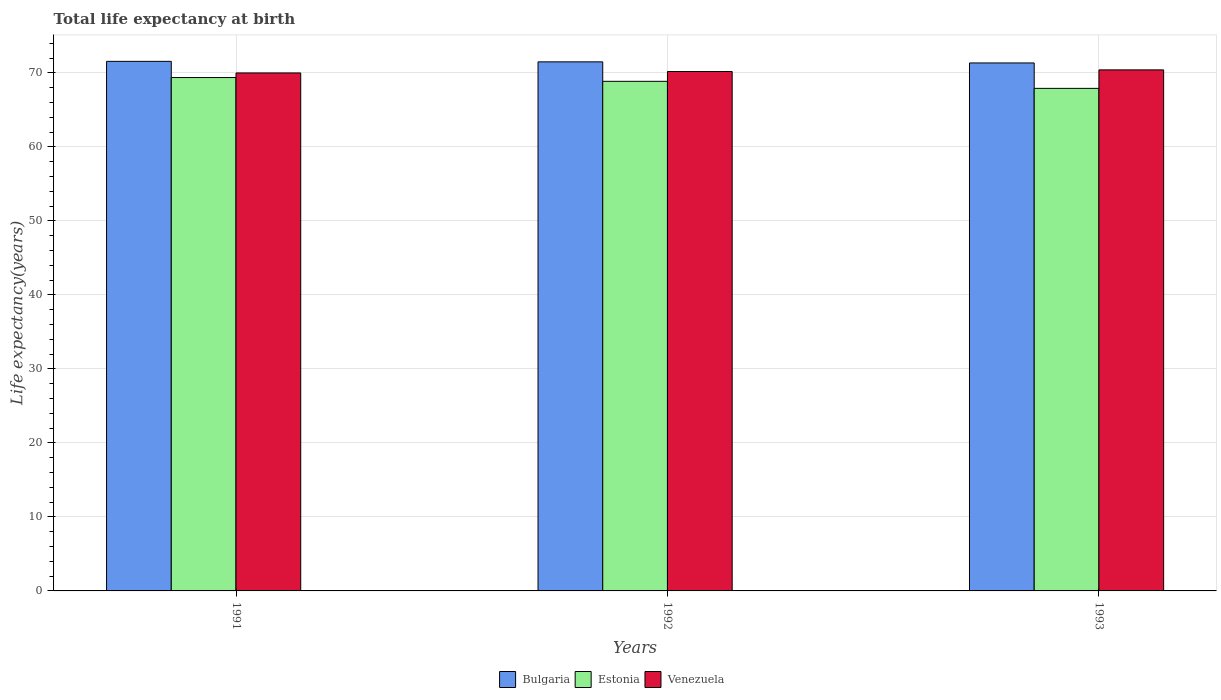How many bars are there on the 2nd tick from the left?
Keep it short and to the point. 3. What is the label of the 1st group of bars from the left?
Your answer should be very brief. 1991. In how many cases, is the number of bars for a given year not equal to the number of legend labels?
Offer a very short reply. 0. What is the life expectancy at birth in in Estonia in 1991?
Keep it short and to the point. 69.37. Across all years, what is the maximum life expectancy at birth in in Venezuela?
Your response must be concise. 70.41. Across all years, what is the minimum life expectancy at birth in in Bulgaria?
Keep it short and to the point. 71.35. In which year was the life expectancy at birth in in Bulgaria maximum?
Provide a short and direct response. 1991. What is the total life expectancy at birth in in Bulgaria in the graph?
Provide a succinct answer. 214.4. What is the difference between the life expectancy at birth in in Venezuela in 1991 and that in 1992?
Offer a terse response. -0.19. What is the difference between the life expectancy at birth in in Venezuela in 1992 and the life expectancy at birth in in Bulgaria in 1991?
Your answer should be compact. -1.37. What is the average life expectancy at birth in in Bulgaria per year?
Give a very brief answer. 71.47. In the year 1993, what is the difference between the life expectancy at birth in in Estonia and life expectancy at birth in in Bulgaria?
Keep it short and to the point. -3.44. In how many years, is the life expectancy at birth in in Bulgaria greater than 4 years?
Give a very brief answer. 3. What is the ratio of the life expectancy at birth in in Estonia in 1992 to that in 1993?
Your response must be concise. 1.01. What is the difference between the highest and the second highest life expectancy at birth in in Bulgaria?
Give a very brief answer. 0.07. What is the difference between the highest and the lowest life expectancy at birth in in Venezuela?
Keep it short and to the point. 0.42. What does the 1st bar from the left in 1991 represents?
Offer a terse response. Bulgaria. What does the 2nd bar from the right in 1993 represents?
Make the answer very short. Estonia. Are all the bars in the graph horizontal?
Your response must be concise. No. How many years are there in the graph?
Provide a succinct answer. 3. Where does the legend appear in the graph?
Offer a terse response. Bottom center. How are the legend labels stacked?
Your response must be concise. Horizontal. What is the title of the graph?
Provide a short and direct response. Total life expectancy at birth. Does "United Kingdom" appear as one of the legend labels in the graph?
Ensure brevity in your answer.  No. What is the label or title of the Y-axis?
Your response must be concise. Life expectancy(years). What is the Life expectancy(years) in Bulgaria in 1991?
Offer a terse response. 71.56. What is the Life expectancy(years) in Estonia in 1991?
Provide a succinct answer. 69.37. What is the Life expectancy(years) in Venezuela in 1991?
Your answer should be compact. 69.99. What is the Life expectancy(years) of Bulgaria in 1992?
Offer a terse response. 71.49. What is the Life expectancy(years) in Estonia in 1992?
Your answer should be compact. 68.86. What is the Life expectancy(years) of Venezuela in 1992?
Offer a very short reply. 70.19. What is the Life expectancy(years) of Bulgaria in 1993?
Make the answer very short. 71.35. What is the Life expectancy(years) in Estonia in 1993?
Your answer should be compact. 67.91. What is the Life expectancy(years) of Venezuela in 1993?
Your answer should be very brief. 70.41. Across all years, what is the maximum Life expectancy(years) of Bulgaria?
Provide a short and direct response. 71.56. Across all years, what is the maximum Life expectancy(years) in Estonia?
Make the answer very short. 69.37. Across all years, what is the maximum Life expectancy(years) of Venezuela?
Keep it short and to the point. 70.41. Across all years, what is the minimum Life expectancy(years) of Bulgaria?
Your response must be concise. 71.35. Across all years, what is the minimum Life expectancy(years) of Estonia?
Provide a short and direct response. 67.91. Across all years, what is the minimum Life expectancy(years) of Venezuela?
Give a very brief answer. 69.99. What is the total Life expectancy(years) in Bulgaria in the graph?
Your answer should be compact. 214.4. What is the total Life expectancy(years) of Estonia in the graph?
Your answer should be compact. 206.15. What is the total Life expectancy(years) of Venezuela in the graph?
Provide a short and direct response. 210.59. What is the difference between the Life expectancy(years) of Bulgaria in 1991 and that in 1992?
Give a very brief answer. 0.07. What is the difference between the Life expectancy(years) of Estonia in 1991 and that in 1992?
Ensure brevity in your answer.  0.51. What is the difference between the Life expectancy(years) in Venezuela in 1991 and that in 1992?
Your answer should be compact. -0.19. What is the difference between the Life expectancy(years) of Bulgaria in 1991 and that in 1993?
Your answer should be compact. 0.21. What is the difference between the Life expectancy(years) of Estonia in 1991 and that in 1993?
Keep it short and to the point. 1.46. What is the difference between the Life expectancy(years) in Venezuela in 1991 and that in 1993?
Keep it short and to the point. -0.41. What is the difference between the Life expectancy(years) in Bulgaria in 1992 and that in 1993?
Your answer should be very brief. 0.15. What is the difference between the Life expectancy(years) in Estonia in 1992 and that in 1993?
Your response must be concise. 0.95. What is the difference between the Life expectancy(years) of Venezuela in 1992 and that in 1993?
Your answer should be compact. -0.22. What is the difference between the Life expectancy(years) in Bulgaria in 1991 and the Life expectancy(years) in Estonia in 1992?
Offer a very short reply. 2.7. What is the difference between the Life expectancy(years) in Bulgaria in 1991 and the Life expectancy(years) in Venezuela in 1992?
Give a very brief answer. 1.37. What is the difference between the Life expectancy(years) in Estonia in 1991 and the Life expectancy(years) in Venezuela in 1992?
Provide a short and direct response. -0.81. What is the difference between the Life expectancy(years) in Bulgaria in 1991 and the Life expectancy(years) in Estonia in 1993?
Give a very brief answer. 3.65. What is the difference between the Life expectancy(years) of Bulgaria in 1991 and the Life expectancy(years) of Venezuela in 1993?
Give a very brief answer. 1.15. What is the difference between the Life expectancy(years) in Estonia in 1991 and the Life expectancy(years) in Venezuela in 1993?
Offer a terse response. -1.04. What is the difference between the Life expectancy(years) of Bulgaria in 1992 and the Life expectancy(years) of Estonia in 1993?
Provide a short and direct response. 3.58. What is the difference between the Life expectancy(years) of Bulgaria in 1992 and the Life expectancy(years) of Venezuela in 1993?
Your response must be concise. 1.08. What is the difference between the Life expectancy(years) of Estonia in 1992 and the Life expectancy(years) of Venezuela in 1993?
Offer a terse response. -1.55. What is the average Life expectancy(years) in Bulgaria per year?
Offer a terse response. 71.47. What is the average Life expectancy(years) in Estonia per year?
Offer a terse response. 68.72. What is the average Life expectancy(years) in Venezuela per year?
Provide a succinct answer. 70.2. In the year 1991, what is the difference between the Life expectancy(years) in Bulgaria and Life expectancy(years) in Estonia?
Give a very brief answer. 2.19. In the year 1991, what is the difference between the Life expectancy(years) in Bulgaria and Life expectancy(years) in Venezuela?
Your answer should be compact. 1.57. In the year 1991, what is the difference between the Life expectancy(years) in Estonia and Life expectancy(years) in Venezuela?
Your answer should be compact. -0.62. In the year 1992, what is the difference between the Life expectancy(years) in Bulgaria and Life expectancy(years) in Estonia?
Provide a short and direct response. 2.63. In the year 1992, what is the difference between the Life expectancy(years) of Bulgaria and Life expectancy(years) of Venezuela?
Offer a very short reply. 1.31. In the year 1992, what is the difference between the Life expectancy(years) of Estonia and Life expectancy(years) of Venezuela?
Offer a terse response. -1.32. In the year 1993, what is the difference between the Life expectancy(years) in Bulgaria and Life expectancy(years) in Estonia?
Give a very brief answer. 3.44. In the year 1993, what is the difference between the Life expectancy(years) of Bulgaria and Life expectancy(years) of Venezuela?
Provide a short and direct response. 0.94. In the year 1993, what is the difference between the Life expectancy(years) in Estonia and Life expectancy(years) in Venezuela?
Provide a succinct answer. -2.5. What is the ratio of the Life expectancy(years) of Bulgaria in 1991 to that in 1992?
Make the answer very short. 1. What is the ratio of the Life expectancy(years) in Estonia in 1991 to that in 1992?
Your answer should be very brief. 1.01. What is the ratio of the Life expectancy(years) in Bulgaria in 1991 to that in 1993?
Provide a short and direct response. 1. What is the ratio of the Life expectancy(years) in Estonia in 1991 to that in 1993?
Your response must be concise. 1.02. What is the ratio of the Life expectancy(years) in Venezuela in 1991 to that in 1993?
Ensure brevity in your answer.  0.99. What is the ratio of the Life expectancy(years) of Estonia in 1992 to that in 1993?
Make the answer very short. 1.01. What is the difference between the highest and the second highest Life expectancy(years) in Bulgaria?
Provide a short and direct response. 0.07. What is the difference between the highest and the second highest Life expectancy(years) in Estonia?
Keep it short and to the point. 0.51. What is the difference between the highest and the second highest Life expectancy(years) in Venezuela?
Provide a succinct answer. 0.22. What is the difference between the highest and the lowest Life expectancy(years) in Bulgaria?
Your response must be concise. 0.21. What is the difference between the highest and the lowest Life expectancy(years) in Estonia?
Your answer should be compact. 1.46. What is the difference between the highest and the lowest Life expectancy(years) of Venezuela?
Give a very brief answer. 0.41. 